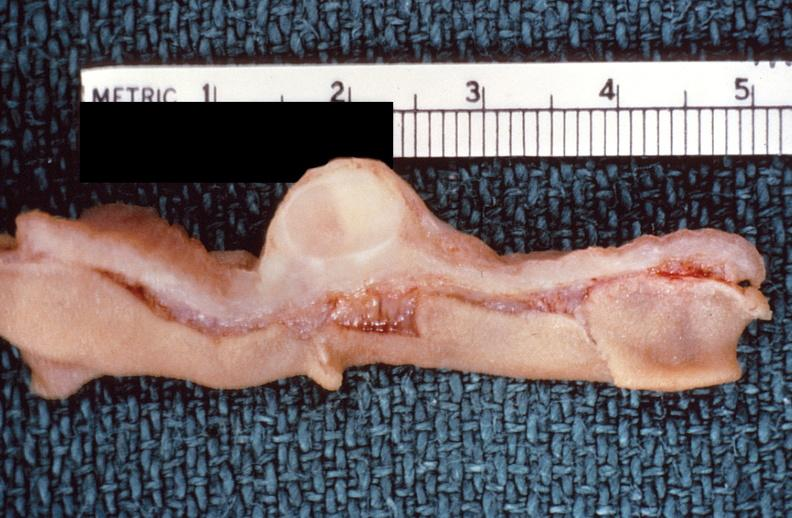where does this belong to?
Answer the question using a single word or phrase. Gastrointestinal system 